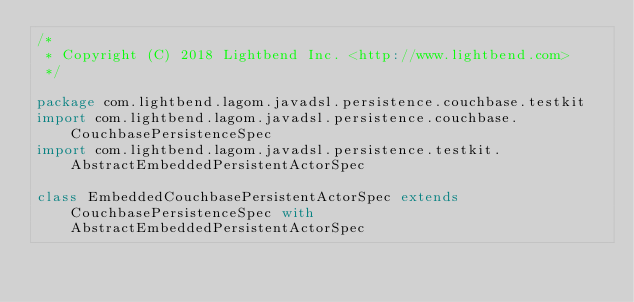<code> <loc_0><loc_0><loc_500><loc_500><_Scala_>/*
 * Copyright (C) 2018 Lightbend Inc. <http://www.lightbend.com>
 */

package com.lightbend.lagom.javadsl.persistence.couchbase.testkit
import com.lightbend.lagom.javadsl.persistence.couchbase.CouchbasePersistenceSpec
import com.lightbend.lagom.javadsl.persistence.testkit.AbstractEmbeddedPersistentActorSpec

class EmbeddedCouchbasePersistentActorSpec extends CouchbasePersistenceSpec with AbstractEmbeddedPersistentActorSpec
</code> 